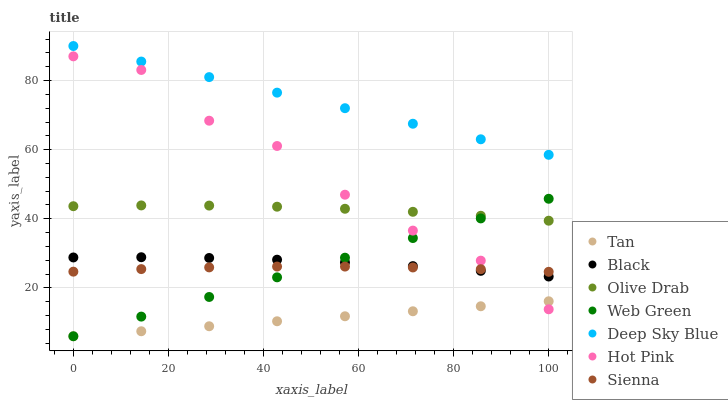Does Tan have the minimum area under the curve?
Answer yes or no. Yes. Does Deep Sky Blue have the maximum area under the curve?
Answer yes or no. Yes. Does Web Green have the minimum area under the curve?
Answer yes or no. No. Does Web Green have the maximum area under the curve?
Answer yes or no. No. Is Tan the smoothest?
Answer yes or no. Yes. Is Hot Pink the roughest?
Answer yes or no. Yes. Is Web Green the smoothest?
Answer yes or no. No. Is Web Green the roughest?
Answer yes or no. No. Does Web Green have the lowest value?
Answer yes or no. Yes. Does Sienna have the lowest value?
Answer yes or no. No. Does Deep Sky Blue have the highest value?
Answer yes or no. Yes. Does Web Green have the highest value?
Answer yes or no. No. Is Olive Drab less than Deep Sky Blue?
Answer yes or no. Yes. Is Deep Sky Blue greater than Sienna?
Answer yes or no. Yes. Does Web Green intersect Hot Pink?
Answer yes or no. Yes. Is Web Green less than Hot Pink?
Answer yes or no. No. Is Web Green greater than Hot Pink?
Answer yes or no. No. Does Olive Drab intersect Deep Sky Blue?
Answer yes or no. No. 